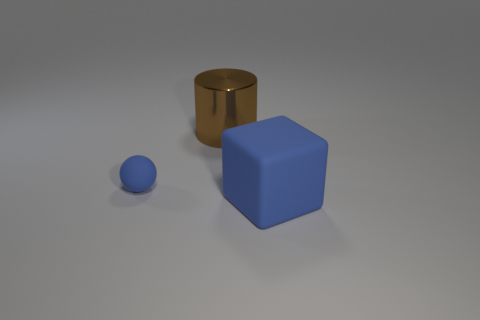Is the color of the object that is behind the tiny thing the same as the matte thing that is behind the block?
Ensure brevity in your answer.  No. Are there more rubber blocks behind the small matte thing than tiny things?
Your response must be concise. No. What number of other things are there of the same color as the matte sphere?
Your response must be concise. 1. There is a blue rubber object to the right of the blue rubber sphere; does it have the same size as the small blue ball?
Your response must be concise. No. Are there any other yellow metallic cylinders that have the same size as the shiny cylinder?
Your response must be concise. No. The matte object that is behind the large blue matte object is what color?
Offer a very short reply. Blue. The thing that is both behind the large cube and in front of the brown cylinder has what shape?
Give a very brief answer. Sphere. What number of brown metal objects have the same shape as the large blue object?
Make the answer very short. 0. How many brown metal cylinders are there?
Keep it short and to the point. 1. What size is the object that is in front of the brown cylinder and behind the big rubber thing?
Your answer should be very brief. Small. 